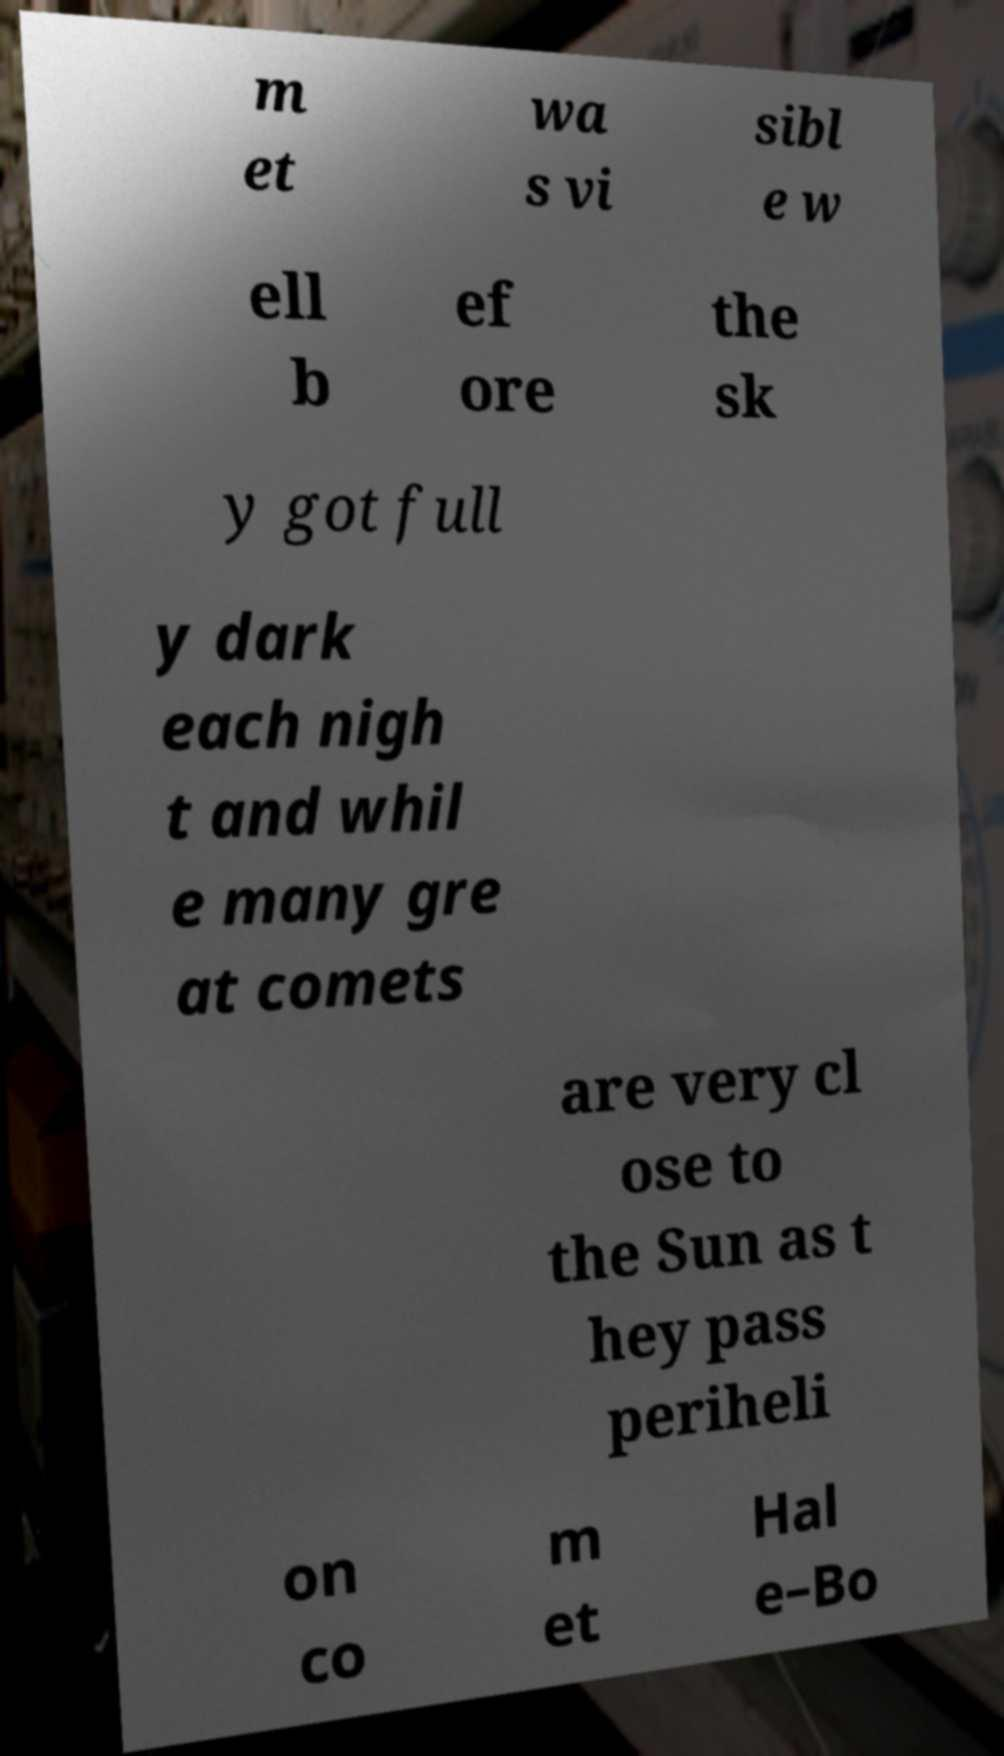Can you read and provide the text displayed in the image?This photo seems to have some interesting text. Can you extract and type it out for me? m et wa s vi sibl e w ell b ef ore the sk y got full y dark each nigh t and whil e many gre at comets are very cl ose to the Sun as t hey pass periheli on co m et Hal e–Bo 